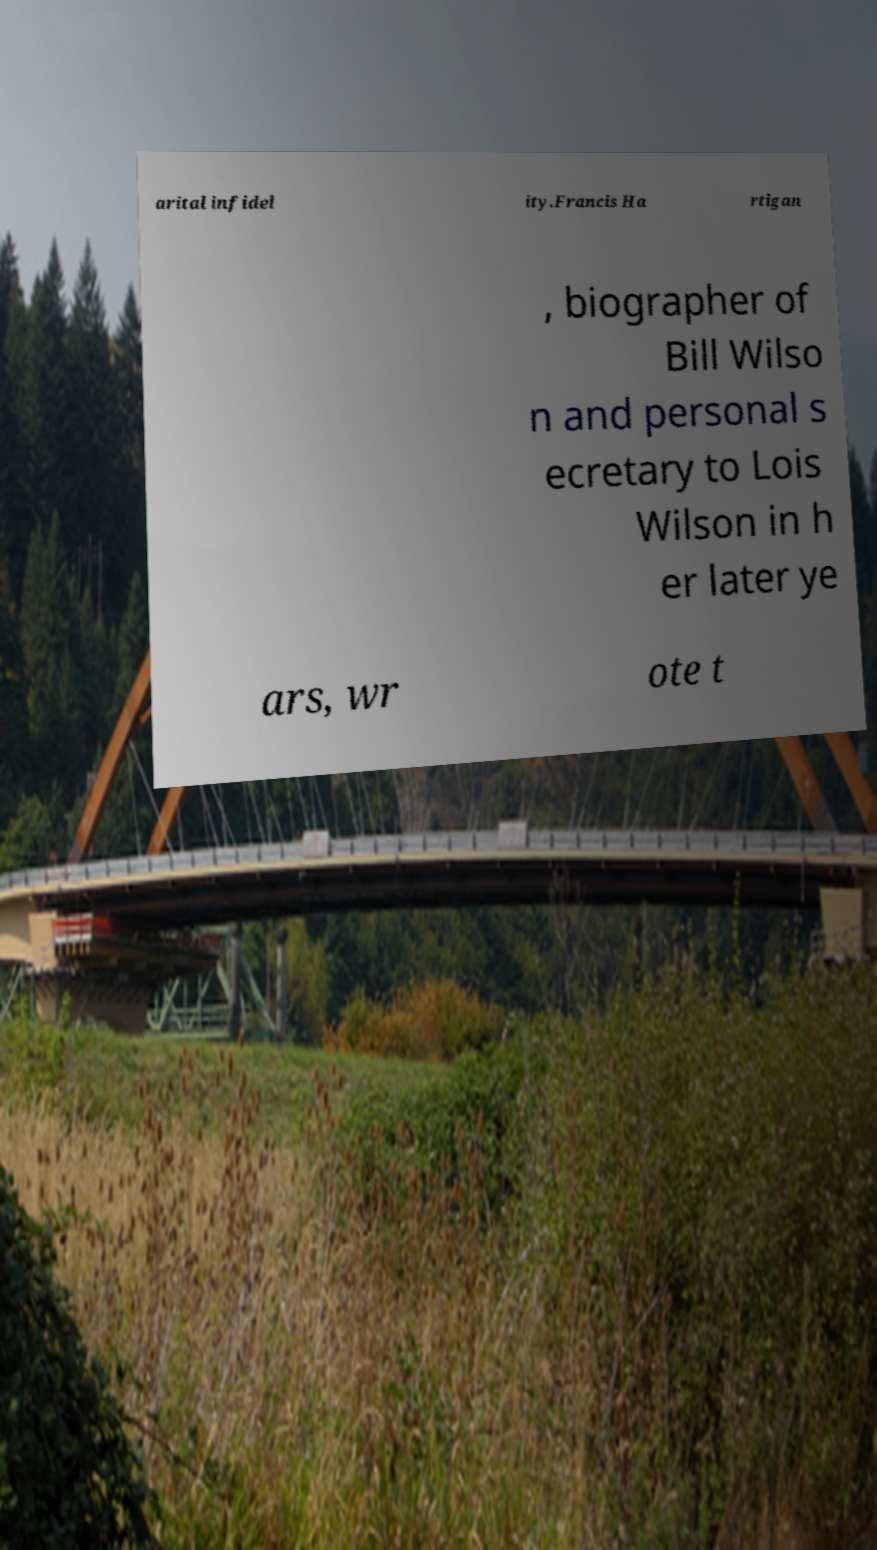Please read and relay the text visible in this image. What does it say? arital infidel ity.Francis Ha rtigan , biographer of Bill Wilso n and personal s ecretary to Lois Wilson in h er later ye ars, wr ote t 